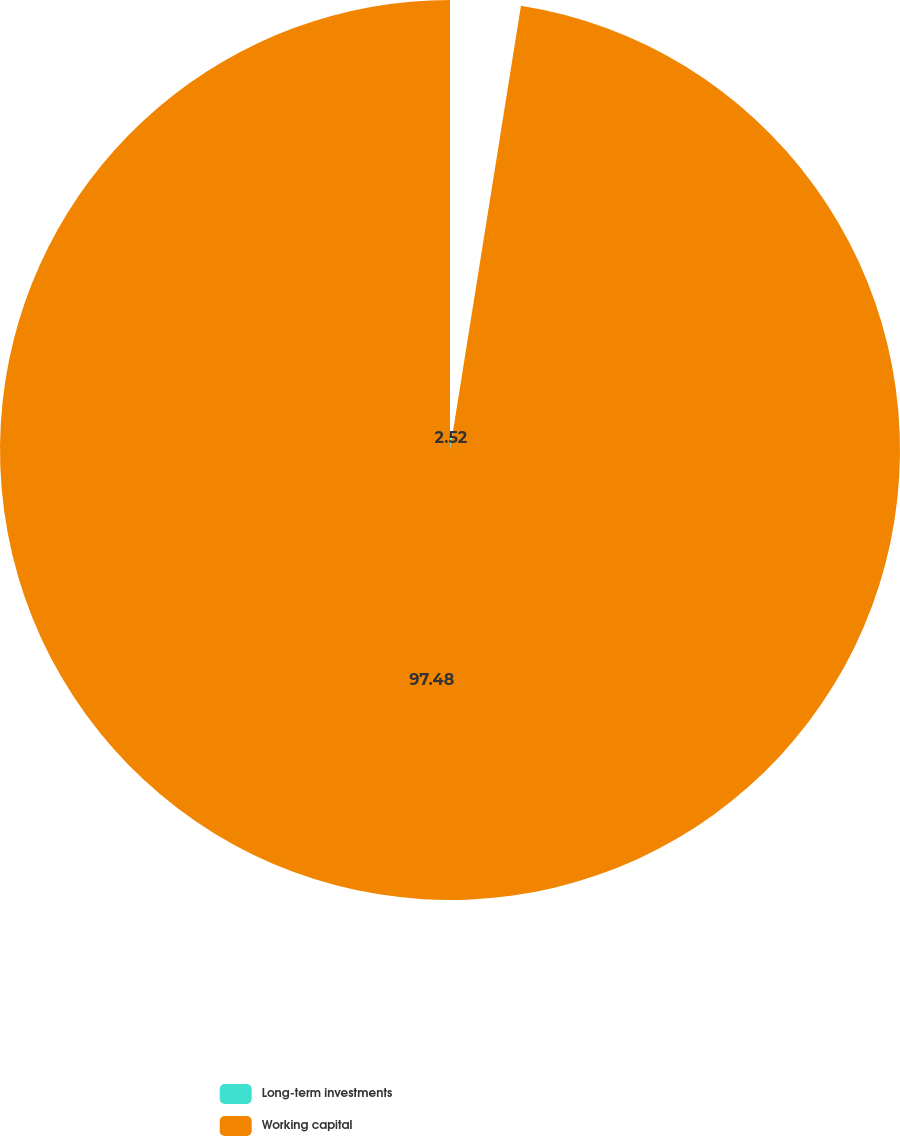Convert chart. <chart><loc_0><loc_0><loc_500><loc_500><pie_chart><fcel>Long-term investments<fcel>Working capital<nl><fcel>2.52%<fcel>97.48%<nl></chart> 